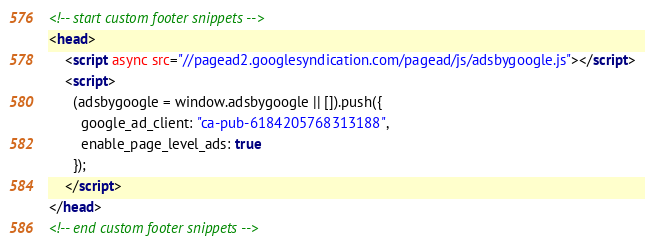<code> <loc_0><loc_0><loc_500><loc_500><_HTML_><!-- start custom footer snippets -->
<head>
    <script async src="//pagead2.googlesyndication.com/pagead/js/adsbygoogle.js"></script>
    <script>
      (adsbygoogle = window.adsbygoogle || []).push({
        google_ad_client: "ca-pub-6184205768313188",
        enable_page_level_ads: true
      });
    </script>
</head>
<!-- end custom footer snippets -->
</code> 